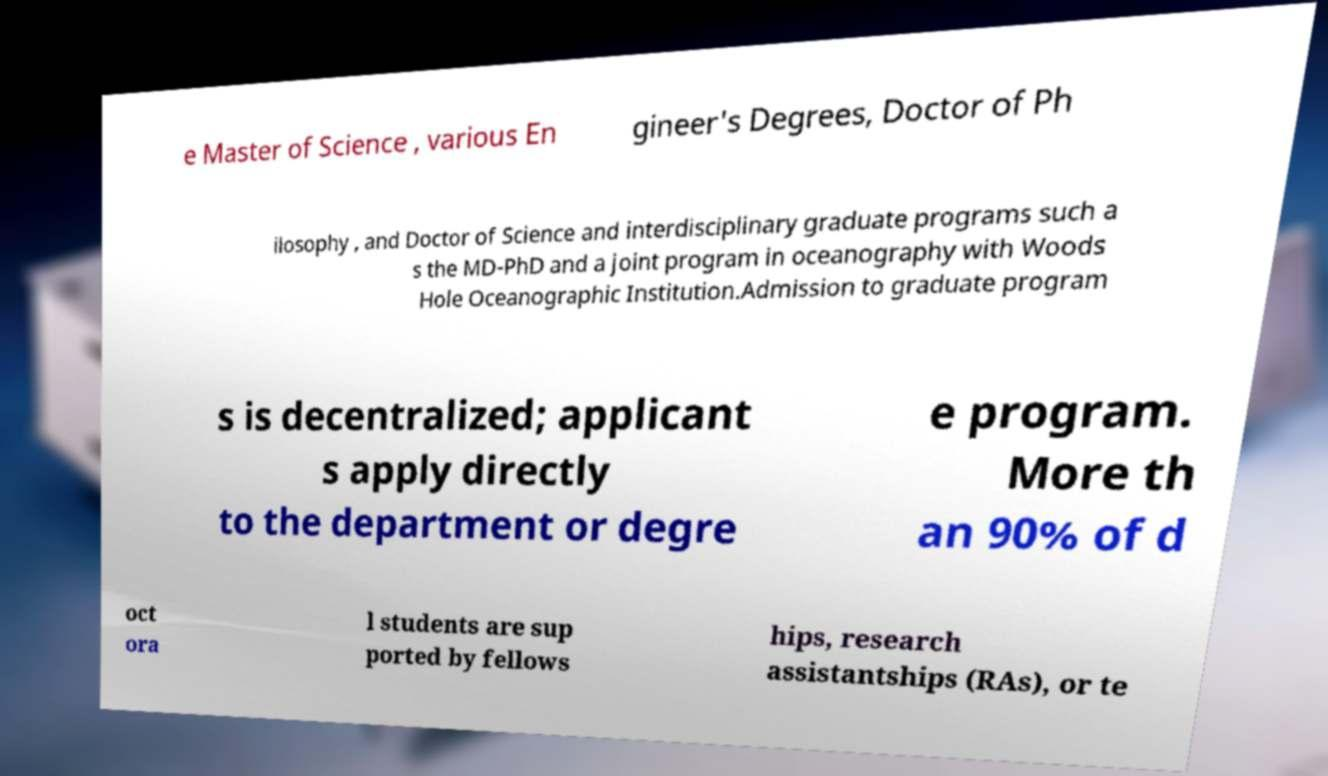There's text embedded in this image that I need extracted. Can you transcribe it verbatim? e Master of Science , various En gineer's Degrees, Doctor of Ph ilosophy , and Doctor of Science and interdisciplinary graduate programs such a s the MD-PhD and a joint program in oceanography with Woods Hole Oceanographic Institution.Admission to graduate program s is decentralized; applicant s apply directly to the department or degre e program. More th an 90% of d oct ora l students are sup ported by fellows hips, research assistantships (RAs), or te 